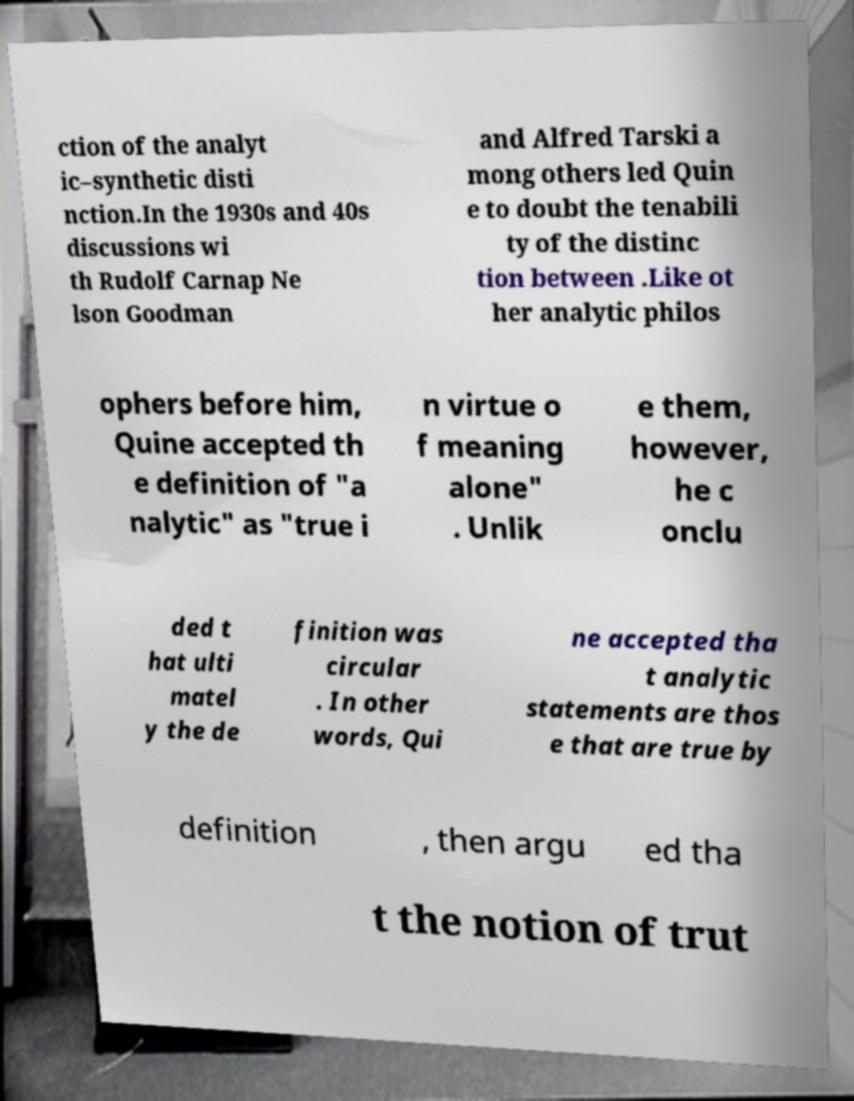Can you read and provide the text displayed in the image?This photo seems to have some interesting text. Can you extract and type it out for me? ction of the analyt ic–synthetic disti nction.In the 1930s and 40s discussions wi th Rudolf Carnap Ne lson Goodman and Alfred Tarski a mong others led Quin e to doubt the tenabili ty of the distinc tion between .Like ot her analytic philos ophers before him, Quine accepted th e definition of "a nalytic" as "true i n virtue o f meaning alone" . Unlik e them, however, he c onclu ded t hat ulti matel y the de finition was circular . In other words, Qui ne accepted tha t analytic statements are thos e that are true by definition , then argu ed tha t the notion of trut 